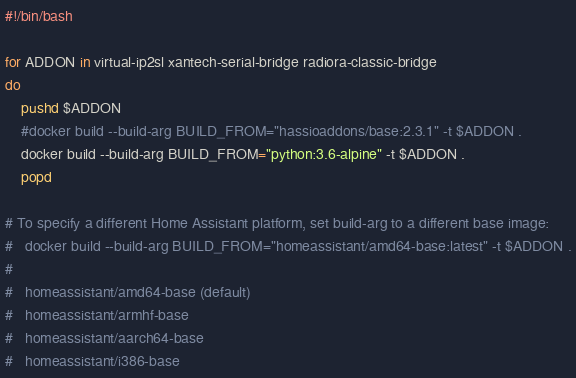<code> <loc_0><loc_0><loc_500><loc_500><_Bash_>#!/bin/bash

for ADDON in virtual-ip2sl xantech-serial-bridge radiora-classic-bridge
do
    pushd $ADDON
    #docker build --build-arg BUILD_FROM="hassioaddons/base:2.3.1" -t $ADDON .
    docker build --build-arg BUILD_FROM="python:3.6-alpine" -t $ADDON .
    popd

# To specify a different Home Assistant platform, set build-arg to a different base image:
#   docker build --build-arg BUILD_FROM="homeassistant/amd64-base:latest" -t $ADDON .
#
#   homeassistant/amd64-base (default)
#   homeassistant/armhf-base
#   homeassistant/aarch64-base
#   homeassistant/i386-base
</code> 